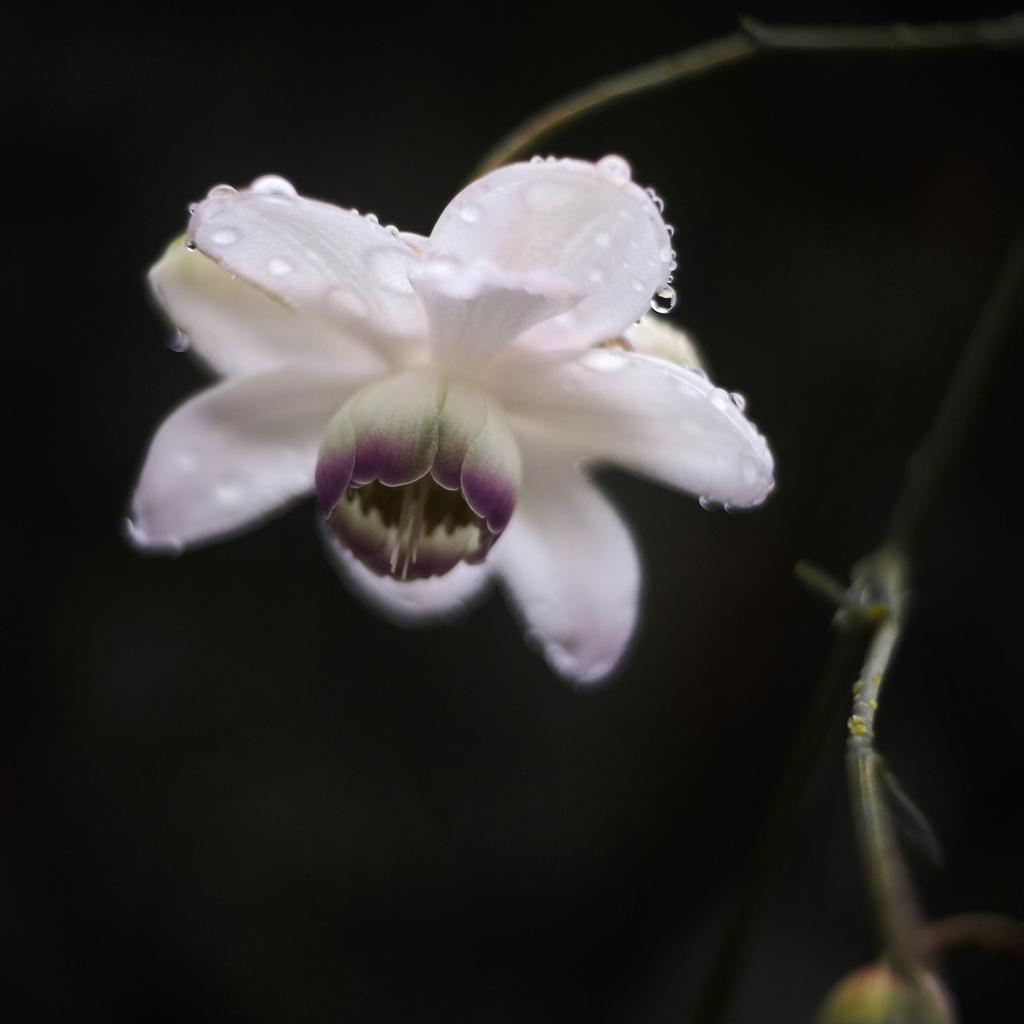What is the main subject of the picture? The main subject of the picture is a flower. Can you describe the flower in the picture? There are water drops on the flower. What grade did the flower receive in the image? There is no indication of a grade in the image, as it features a flower with water drops. 